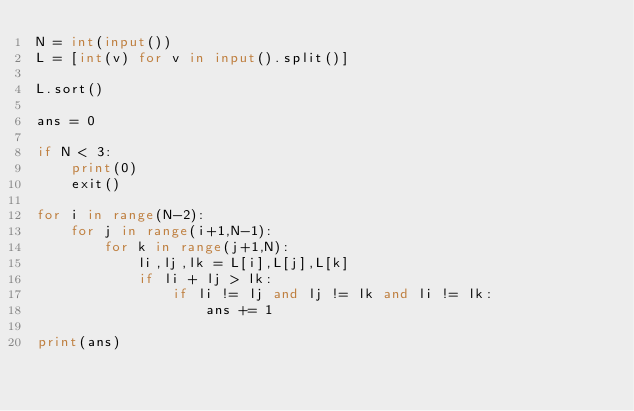<code> <loc_0><loc_0><loc_500><loc_500><_Python_>N = int(input())
L = [int(v) for v in input().split()]

L.sort()

ans = 0

if N < 3:
    print(0)
    exit()

for i in range(N-2):
    for j in range(i+1,N-1):
        for k in range(j+1,N):
            li,lj,lk = L[i],L[j],L[k]
            if li + lj > lk:
                if li != lj and lj != lk and li != lk:
                    ans += 1

print(ans)
</code> 